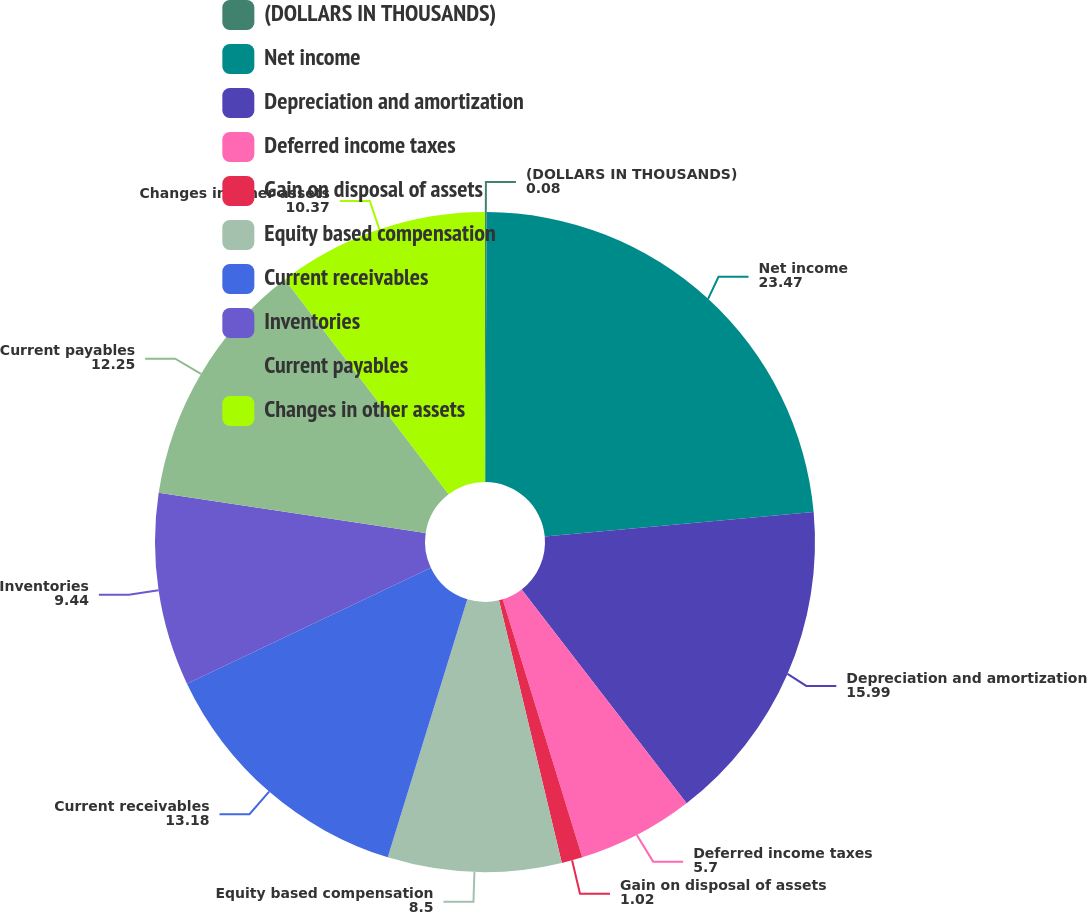Convert chart. <chart><loc_0><loc_0><loc_500><loc_500><pie_chart><fcel>(DOLLARS IN THOUSANDS)<fcel>Net income<fcel>Depreciation and amortization<fcel>Deferred income taxes<fcel>Gain on disposal of assets<fcel>Equity based compensation<fcel>Current receivables<fcel>Inventories<fcel>Current payables<fcel>Changes in other assets<nl><fcel>0.08%<fcel>23.47%<fcel>15.99%<fcel>5.7%<fcel>1.02%<fcel>8.5%<fcel>13.18%<fcel>9.44%<fcel>12.25%<fcel>10.37%<nl></chart> 